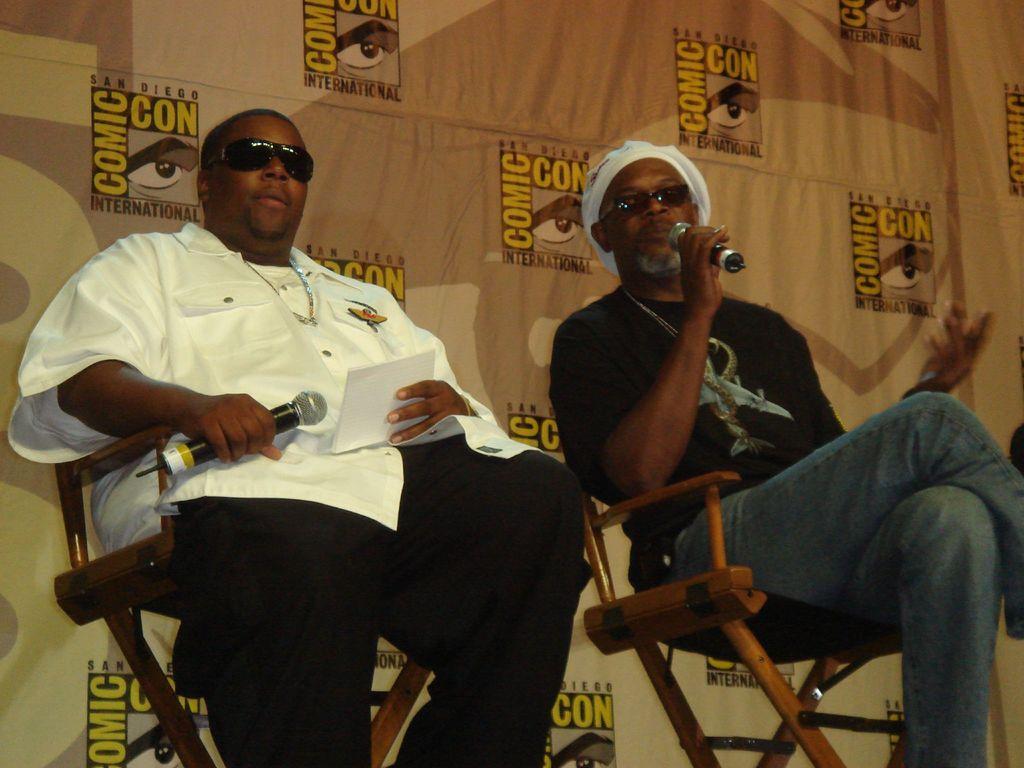Describe this image in one or two sentences. In this picture there are two men sitting on chairs and holding microphones and wore goggles. In the background of the image we can see hoarding. 